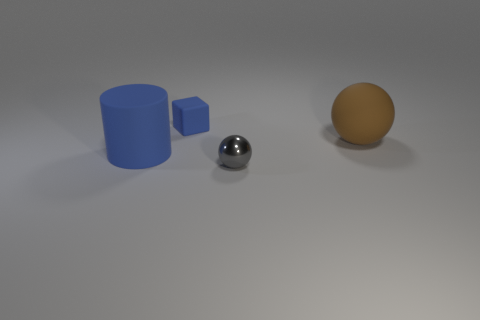Add 2 large cyan balls. How many objects exist? 6 Subtract all blocks. How many objects are left? 3 Subtract 0 gray cylinders. How many objects are left? 4 Subtract all tiny balls. Subtract all brown objects. How many objects are left? 2 Add 4 brown matte things. How many brown matte things are left? 5 Add 3 cyan rubber cylinders. How many cyan rubber cylinders exist? 3 